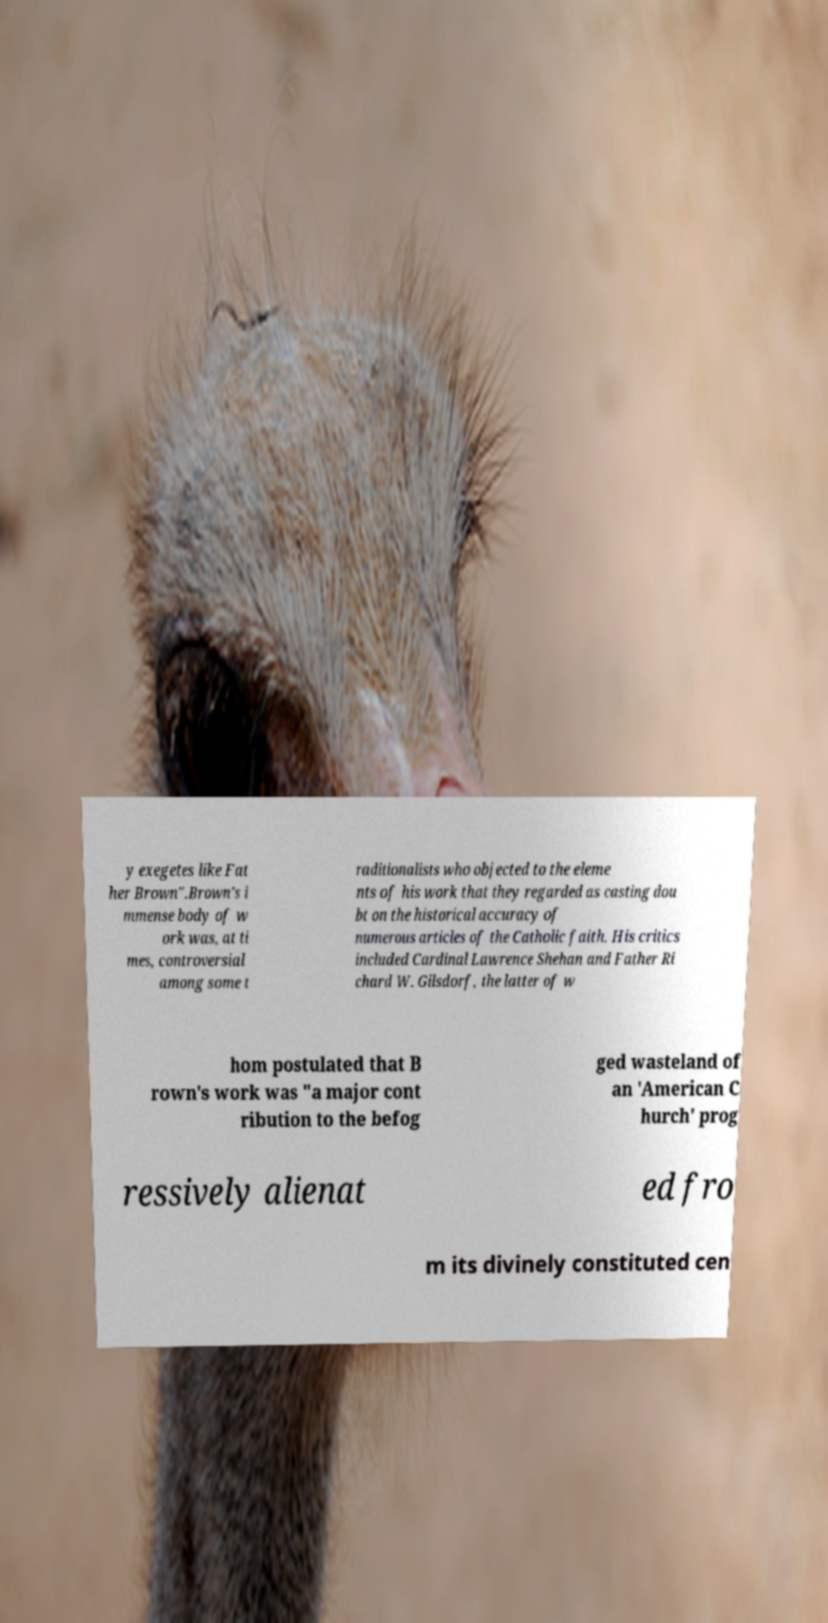Please read and relay the text visible in this image. What does it say? y exegetes like Fat her Brown".Brown's i mmense body of w ork was, at ti mes, controversial among some t raditionalists who objected to the eleme nts of his work that they regarded as casting dou bt on the historical accuracy of numerous articles of the Catholic faith. His critics included Cardinal Lawrence Shehan and Father Ri chard W. Gilsdorf, the latter of w hom postulated that B rown's work was "a major cont ribution to the befog ged wasteland of an 'American C hurch' prog ressively alienat ed fro m its divinely constituted cen 